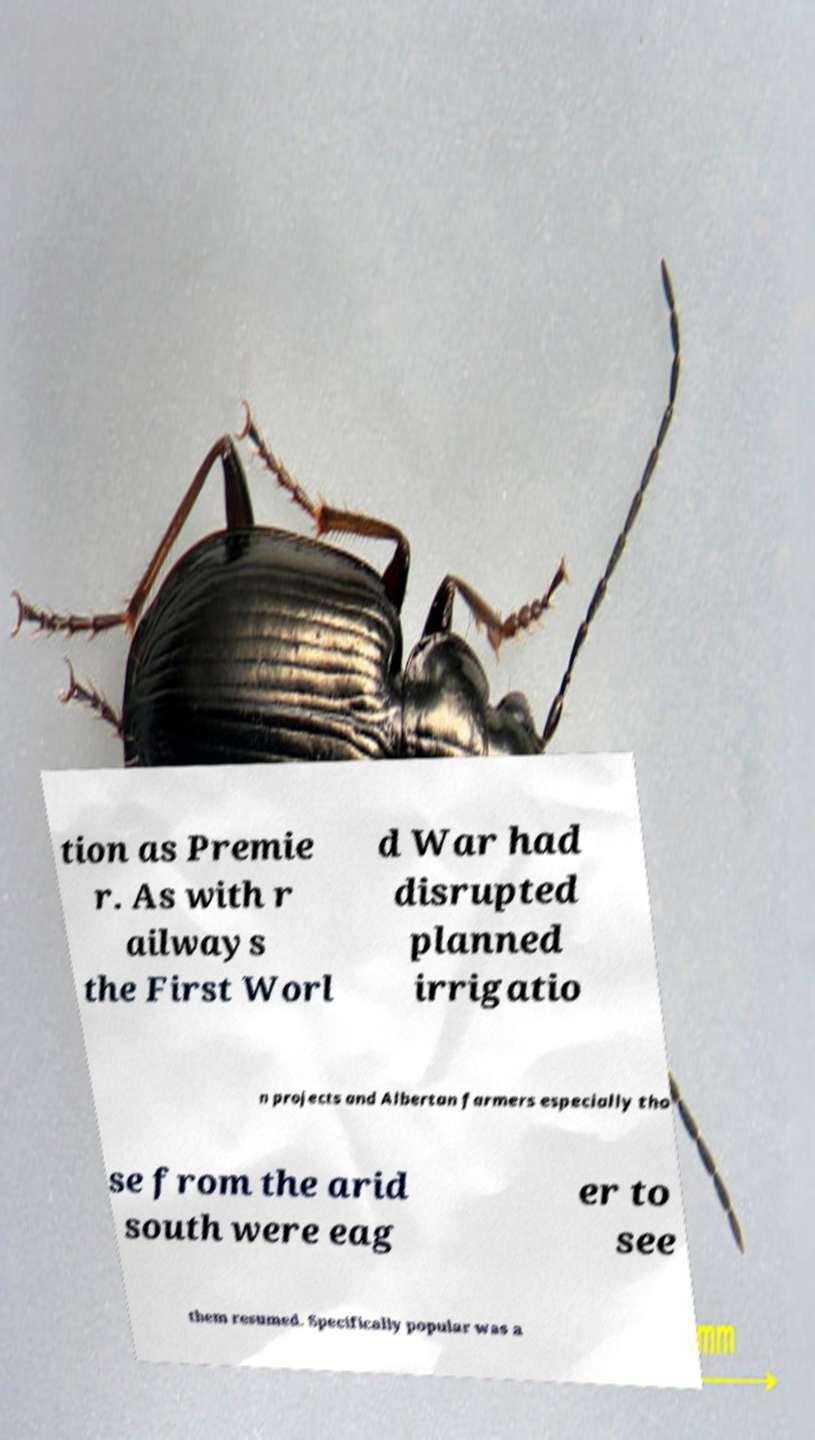Could you assist in decoding the text presented in this image and type it out clearly? tion as Premie r. As with r ailways the First Worl d War had disrupted planned irrigatio n projects and Albertan farmers especially tho se from the arid south were eag er to see them resumed. Specifically popular was a 